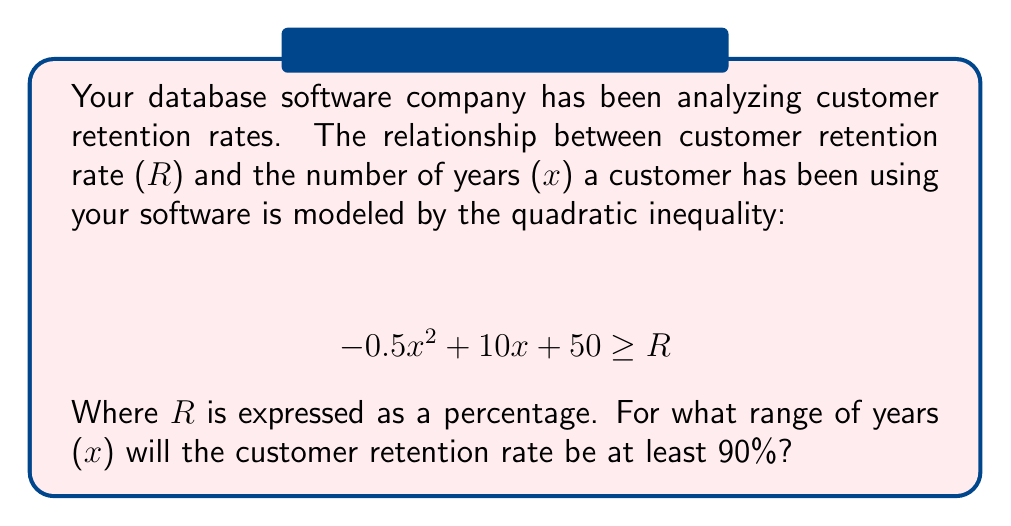Provide a solution to this math problem. To solve this problem, we need to follow these steps:

1) First, we set up the inequality with R = 90:
   $$ -0.5x^2 + 10x + 50 \geq 90 $$

2) Rearrange the inequality to standard form:
   $$ -0.5x^2 + 10x - 40 \geq 0 $$

3) This is a quadratic inequality. To solve it, we first find the roots of the corresponding quadratic equation:
   $$ -0.5x^2 + 10x - 40 = 0 $$

4) We can solve this using the quadratic formula: $x = \frac{-b \pm \sqrt{b^2 - 4ac}}{2a}$
   Where $a = -0.5$, $b = 10$, and $c = -40$

5) Plugging in these values:
   $$ x = \frac{-10 \pm \sqrt{100 - 4(-0.5)(-40)}}{2(-0.5)} = \frac{-10 \pm \sqrt{20}}{-1} $$

6) Simplifying:
   $$ x = 10 \pm 2\sqrt{5} $$

7) So the roots are:
   $$ x_1 = 10 - 2\sqrt{5} \approx 5.53 $$
   $$ x_2 = 10 + 2\sqrt{5} \approx 14.47 $$

8) Since the parabola opens downward (coefficient of $x^2$ is negative), the inequality is satisfied between these two roots.

Therefore, the retention rate will be at least 90% when x is between these two values.
Answer: $10 - 2\sqrt{5} \leq x \leq 10 + 2\sqrt{5}$ 